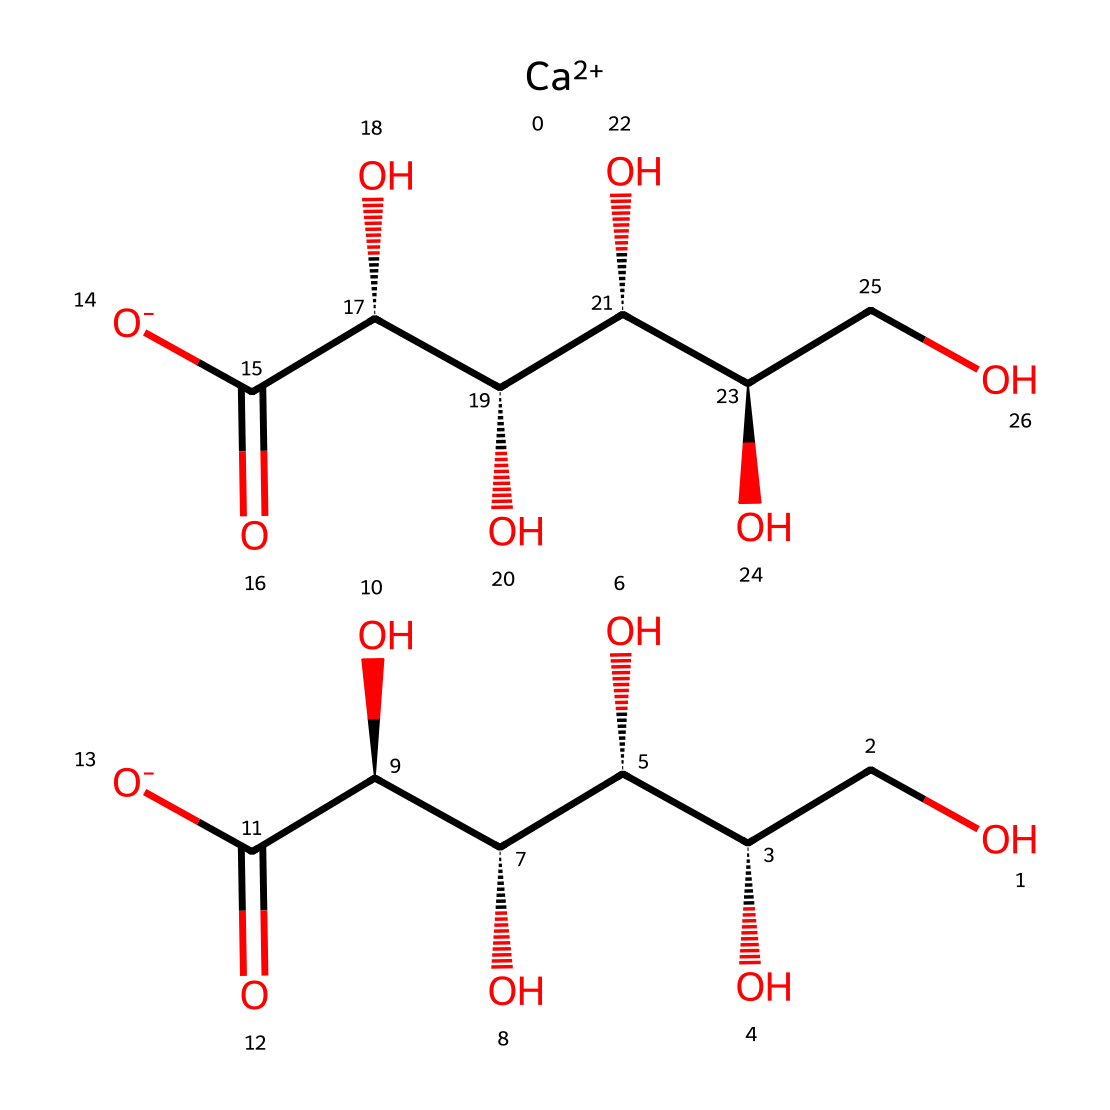What is the central metal ion in calcium gluconate? The chemical structure contains a calcium ion denoted as 'Ca' with a double plus charge, which identifies the presence of calcium as the central metal.
Answer: calcium How many hydroxyl (-OH) groups are present in calcium gluconate? By analyzing the structural representation, I can count six hydroxyl groups represented as -OH in the two glucose units.
Answer: six What could be a reason for using calcium gluconate over calcium chloride in medical treatments? Calcium gluconate is less irritating and has a more balanced pH compared to calcium chloride, reducing the risk of tissue damage upon administration.
Answer: less irritating What is the primary function of calcium gluconate in medical treatments? Calcium gluconate primarily serves to supplement calcium levels in patients with hypocalcemia, helping maintain bone health and proper muscle function.
Answer: supplement calcium How many carbon atoms are there in calcium gluconate? By detailing the structure and counting the carbons in the two glucose units, I can conclude there are 12 carbon atoms total in the entire molecule.
Answer: twelve 